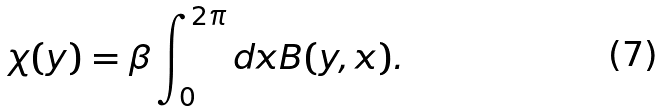Convert formula to latex. <formula><loc_0><loc_0><loc_500><loc_500>\chi ( y ) = \beta \int _ { 0 } ^ { 2 \pi } d x B ( y , x ) .</formula> 